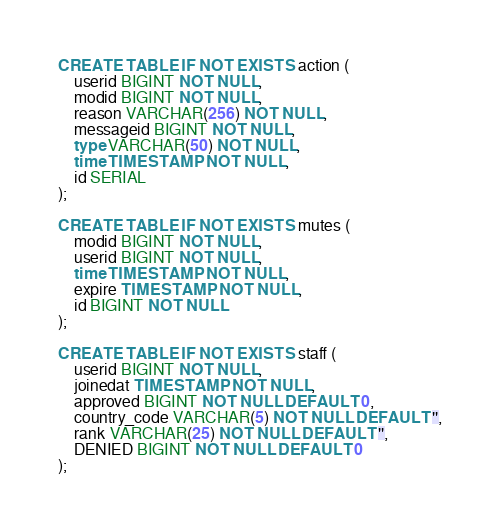<code> <loc_0><loc_0><loc_500><loc_500><_SQL_>CREATE TABLE IF NOT EXISTS action (
    userid BIGINT NOT NULL,
    modid BIGINT NOT NULL,
    reason VARCHAR(256) NOT NULL,
    messageid BIGINT NOT NULL,
    type VARCHAR(50) NOT NULL,
    time TIMESTAMP NOT NULL,
    id SERIAL
);

CREATE TABLE IF NOT EXISTS mutes (
    modid BIGINT NOT NULL,
    userid BIGINT NOT NULL,
    time TIMESTAMP NOT NULL,
    expire TIMESTAMP NOT NULL,
    id BIGINT NOT NULL
);

CREATE TABLE IF NOT EXISTS staff (
    userid BIGINT NOT NULL,
    joinedat TIMESTAMP NOT NULL,
    approved BIGINT NOT NULL DEFAULT 0,
    country_code VARCHAR(5) NOT NULL DEFAULT '',
    rank VARCHAR(25) NOT NULL DEFAULT '',
    DENIED BIGINT NOT NULL DEFAULT 0
);</code> 